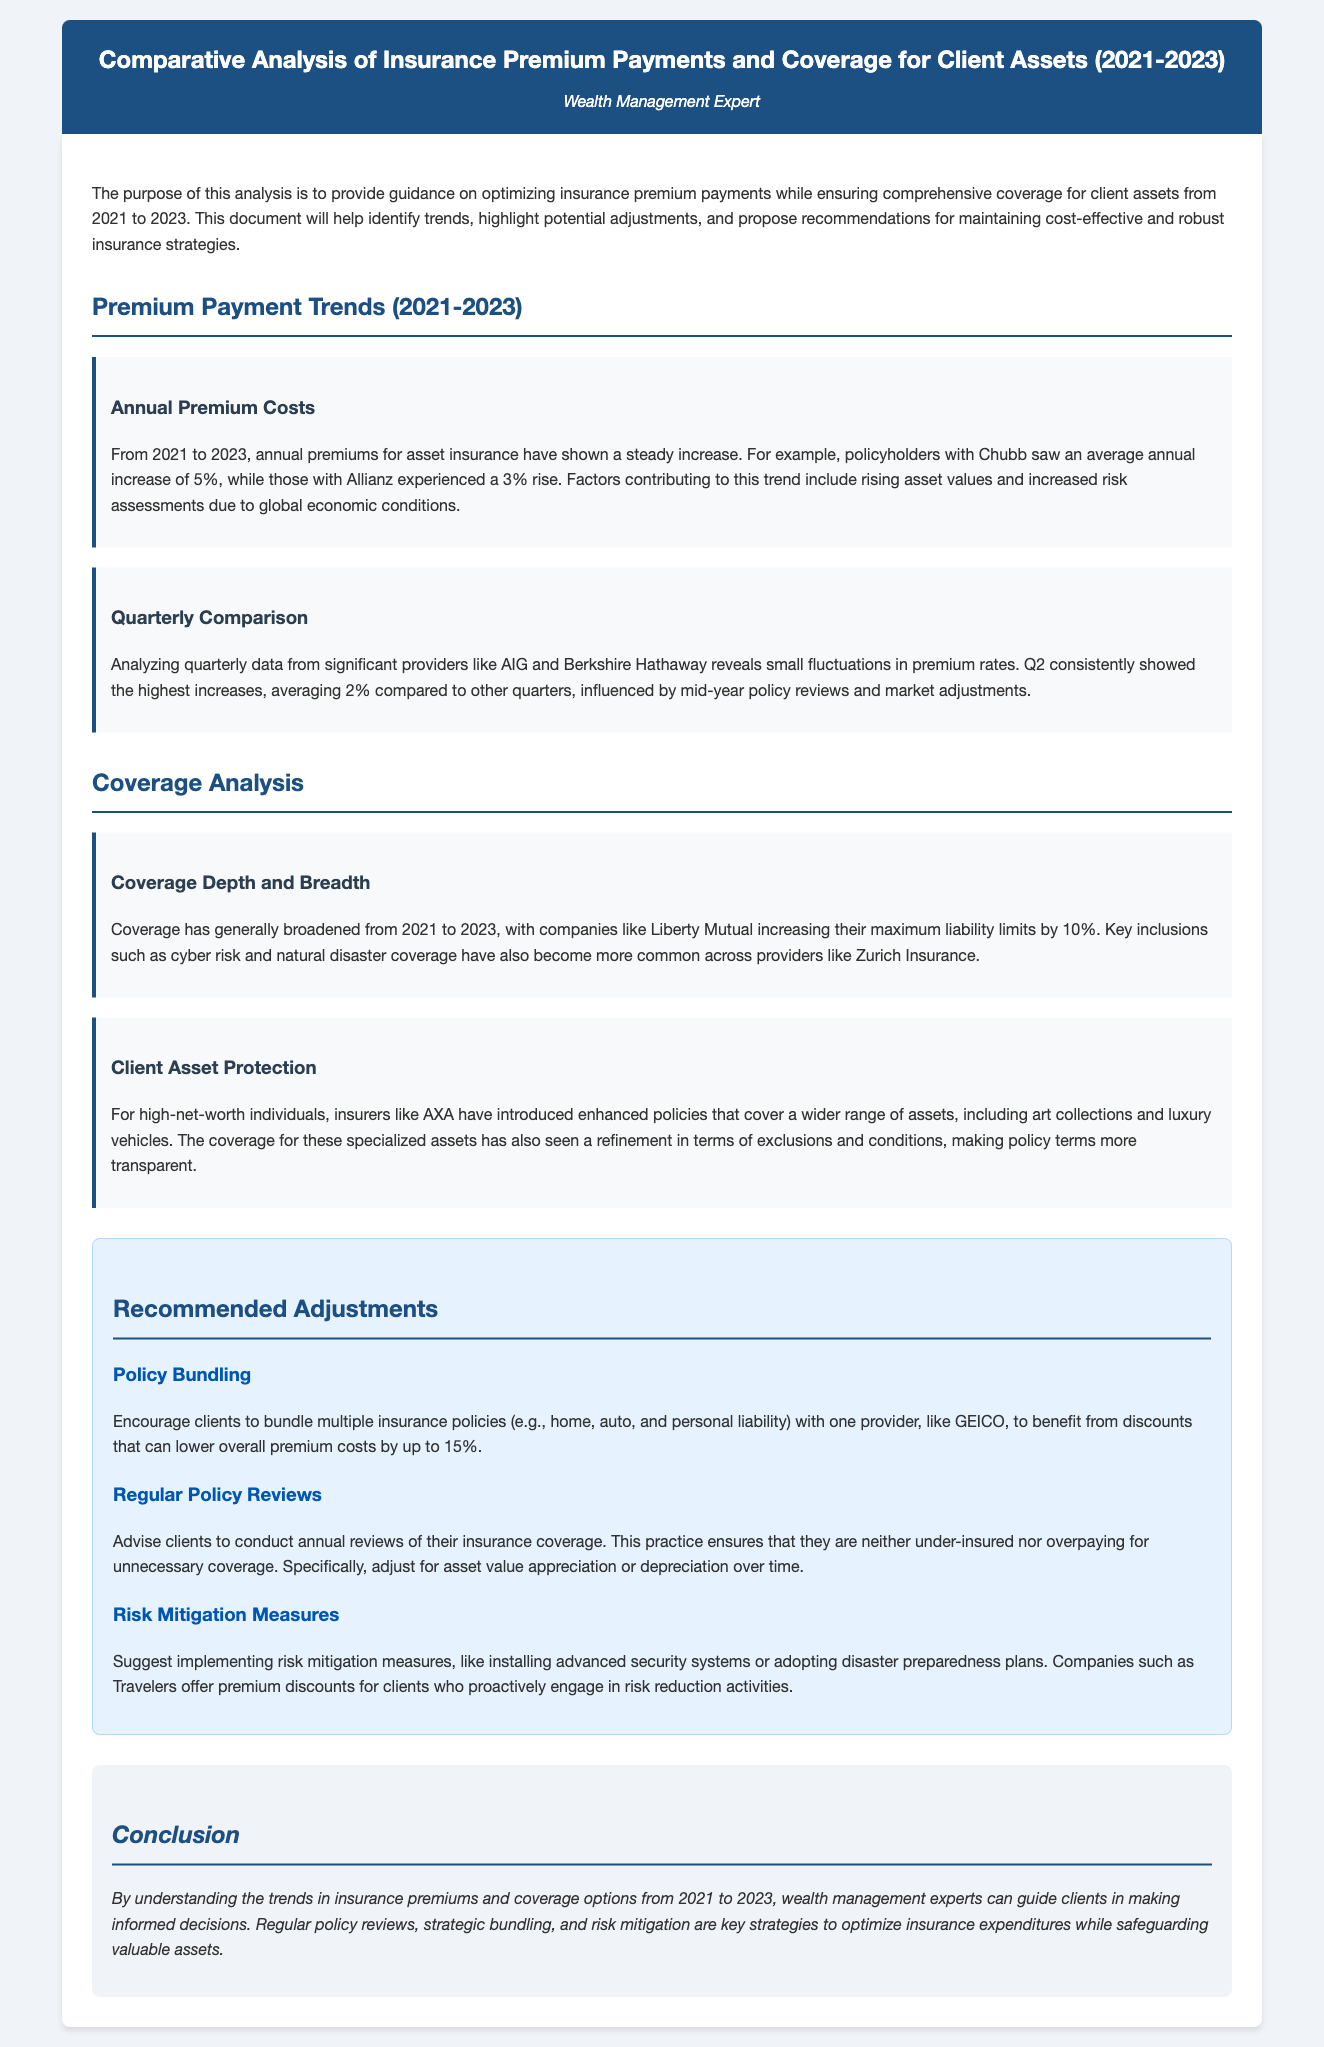What is the average annual increase in premiums for Chubb from 2021 to 2023? The document states that policyholders with Chubb saw an average annual increase of 5%.
Answer: 5% Which quarter showed the highest increases in premium rates? The analysis reveals that Q2 consistently showed the highest increases, averaging 2% compared to other quarters.
Answer: Q2 What percentage increase in maximum liability limits was noted for policies from Liberty Mutual? The document mentions that Liberty Mutual increased their maximum liability limits by 10%.
Answer: 10% What is one recommendation related to policy bundling? The document advises clients to bundle multiple insurance policies with one provider to benefit from discounts that can lower overall premium costs by up to 15%.
Answer: 15% Which insurer introduced enhanced policies for high-net-worth individuals? The analysis highlights that insurers like AXA introduced enhanced policies covering a wider range of assets.
Answer: AXA What is one of the key strategies mentioned for optimizing insurance expenditures? The conclusion emphasizes regular policy reviews as a key strategy to optimize insurance expenditures.
Answer: Regular policy reviews Which company offers premium discounts for implementing risk mitigation measures? The document indicates that companies such as Travelers offer premium discounts for clients engaging in risk reduction activities.
Answer: Travelers What is the purpose of this analysis? The document states that the purpose is to provide guidance on optimizing insurance premium payments while ensuring comprehensive coverage for client assets.
Answer: Guidance on optimizing insurance premium payments 